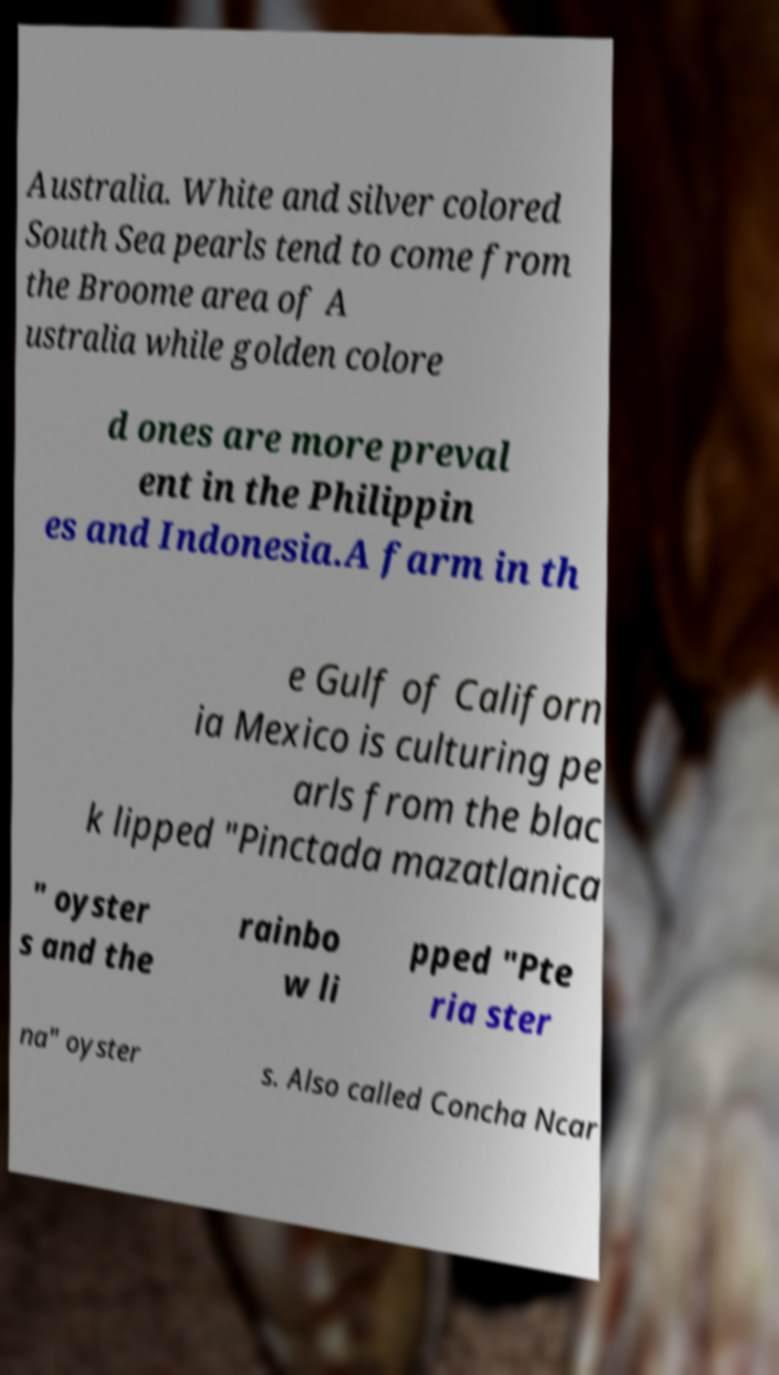Can you accurately transcribe the text from the provided image for me? Australia. White and silver colored South Sea pearls tend to come from the Broome area of A ustralia while golden colore d ones are more preval ent in the Philippin es and Indonesia.A farm in th e Gulf of Californ ia Mexico is culturing pe arls from the blac k lipped "Pinctada mazatlanica " oyster s and the rainbo w li pped "Pte ria ster na" oyster s. Also called Concha Ncar 